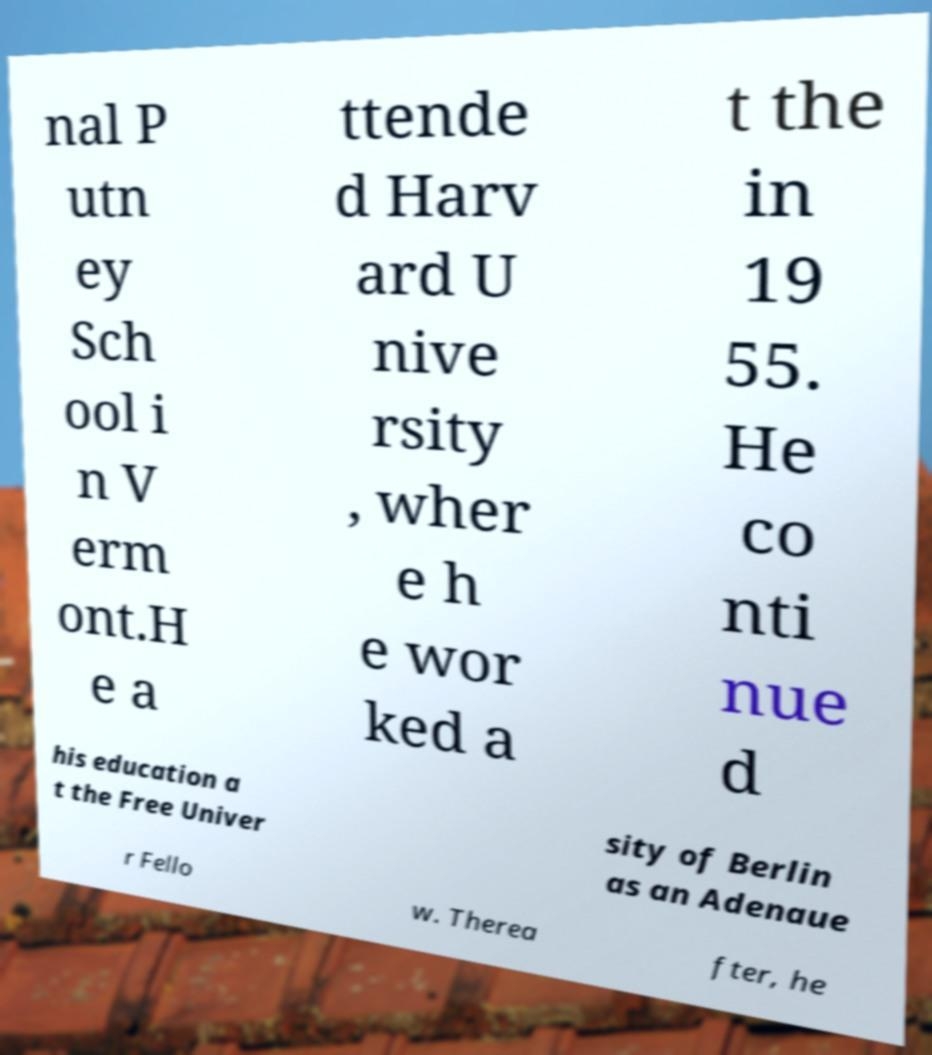Could you extract and type out the text from this image? nal P utn ey Sch ool i n V erm ont.H e a ttende d Harv ard U nive rsity , wher e h e wor ked a t the in 19 55. He co nti nue d his education a t the Free Univer sity of Berlin as an Adenaue r Fello w. Therea fter, he 